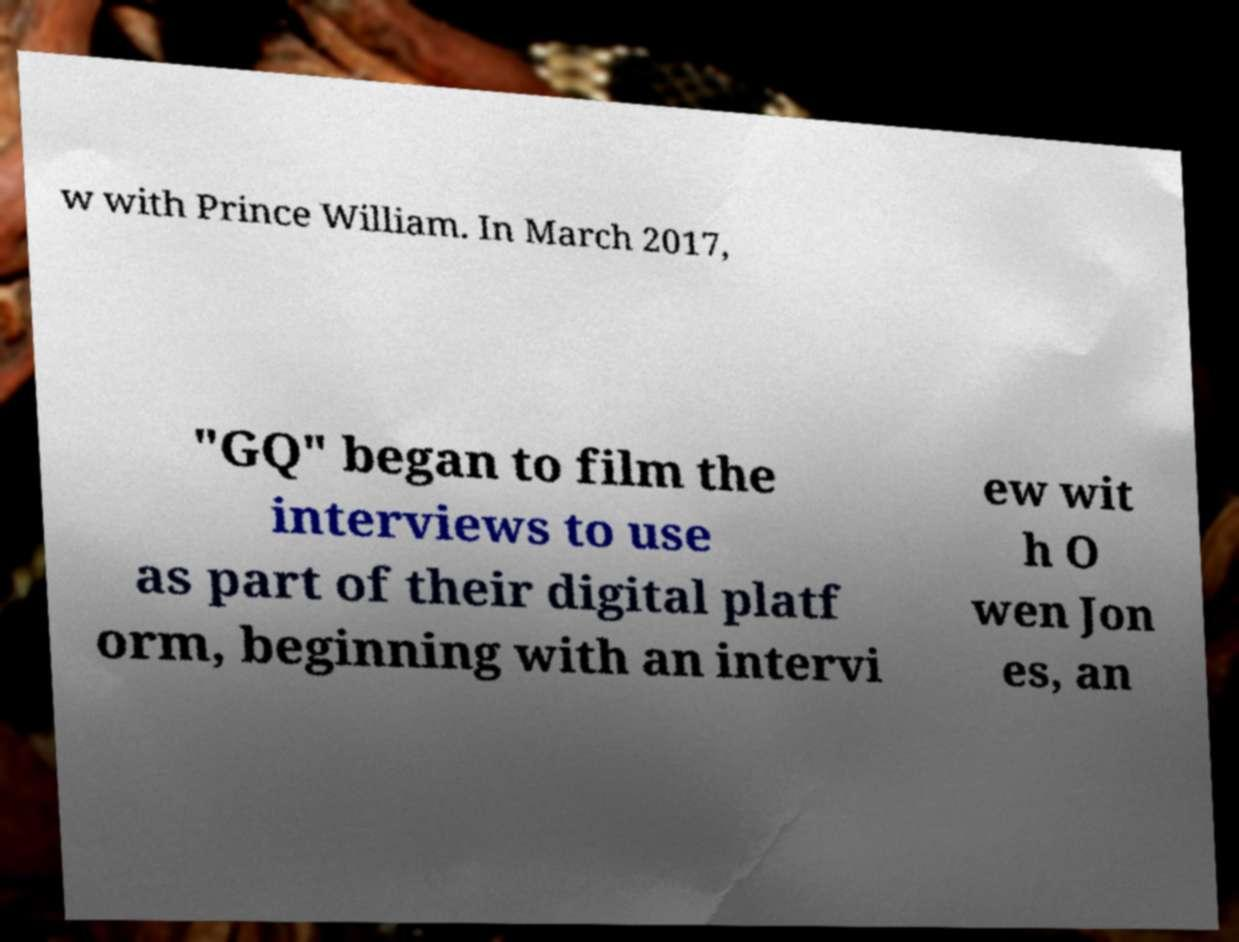Can you read and provide the text displayed in the image?This photo seems to have some interesting text. Can you extract and type it out for me? w with Prince William. In March 2017, "GQ" began to film the interviews to use as part of their digital platf orm, beginning with an intervi ew wit h O wen Jon es, an 